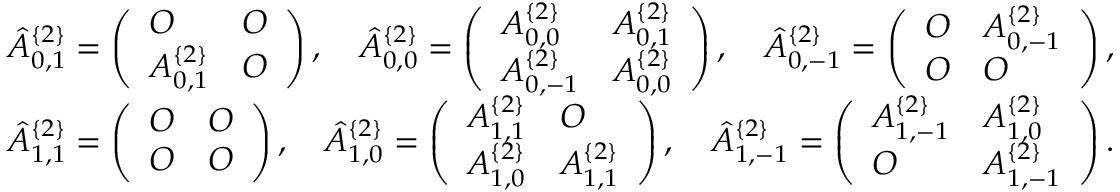Convert formula to latex. <formula><loc_0><loc_0><loc_500><loc_500>\begin{array} { r } { \hat { A } _ { 0 , 1 } ^ { \{ 2 \} } = \left ( \begin{array} { l l } { O } & { O } \\ { A _ { 0 , 1 } ^ { \{ 2 \} } } & { O } \end{array} \right ) , \quad \hat { A } _ { 0 , 0 } ^ { \{ 2 \} } = \left ( \begin{array} { l l } { A _ { 0 , 0 } ^ { \{ 2 \} } } & { A _ { 0 , 1 } ^ { \{ 2 \} } } \\ { A _ { 0 , - 1 } ^ { \{ 2 \} } } & { A _ { 0 , 0 } ^ { \{ 2 \} } } \end{array} \right ) , \quad \hat { A } _ { 0 , - 1 } ^ { \{ 2 \} } = \left ( \begin{array} { l l } { O } & { A _ { 0 , - 1 } ^ { \{ 2 \} } } \\ { O } & { O } \end{array} \right ) , } \\ { \hat { A } _ { 1 , 1 } ^ { \{ 2 \} } = \left ( \begin{array} { l l } { O } & { O } \\ { O } & { O } \end{array} \right ) , \quad \hat { A } _ { 1 , 0 } ^ { \{ 2 \} } = \left ( \begin{array} { l l } { A _ { 1 , 1 } ^ { \{ 2 \} } } & { O } \\ { A _ { 1 , 0 } ^ { \{ 2 \} } } & { A _ { 1 , 1 } ^ { \{ 2 \} } } \end{array} \right ) , \quad \hat { A } _ { 1 , - 1 } ^ { \{ 2 \} } = \left ( \begin{array} { l l } { A _ { 1 , - 1 } ^ { \{ 2 \} } } & { A _ { 1 , 0 } ^ { \{ 2 \} } } \\ { O } & { A _ { 1 , - 1 } ^ { \{ 2 \} } } \end{array} \right ) . } \end{array}</formula> 